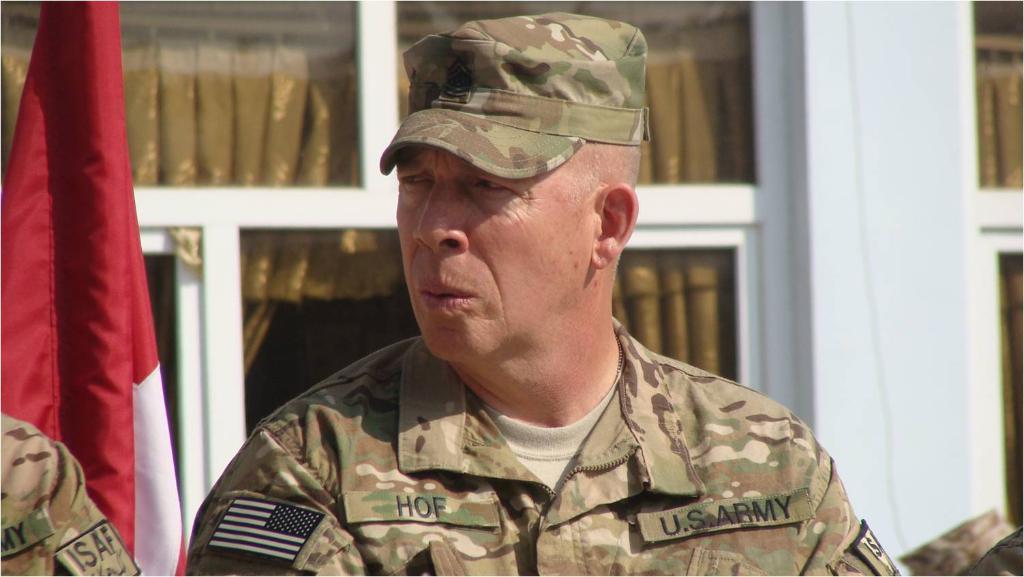Please provide a concise description of this image. In the center of the image we can see person. In the background we can see flag, windows,curtain and building. 